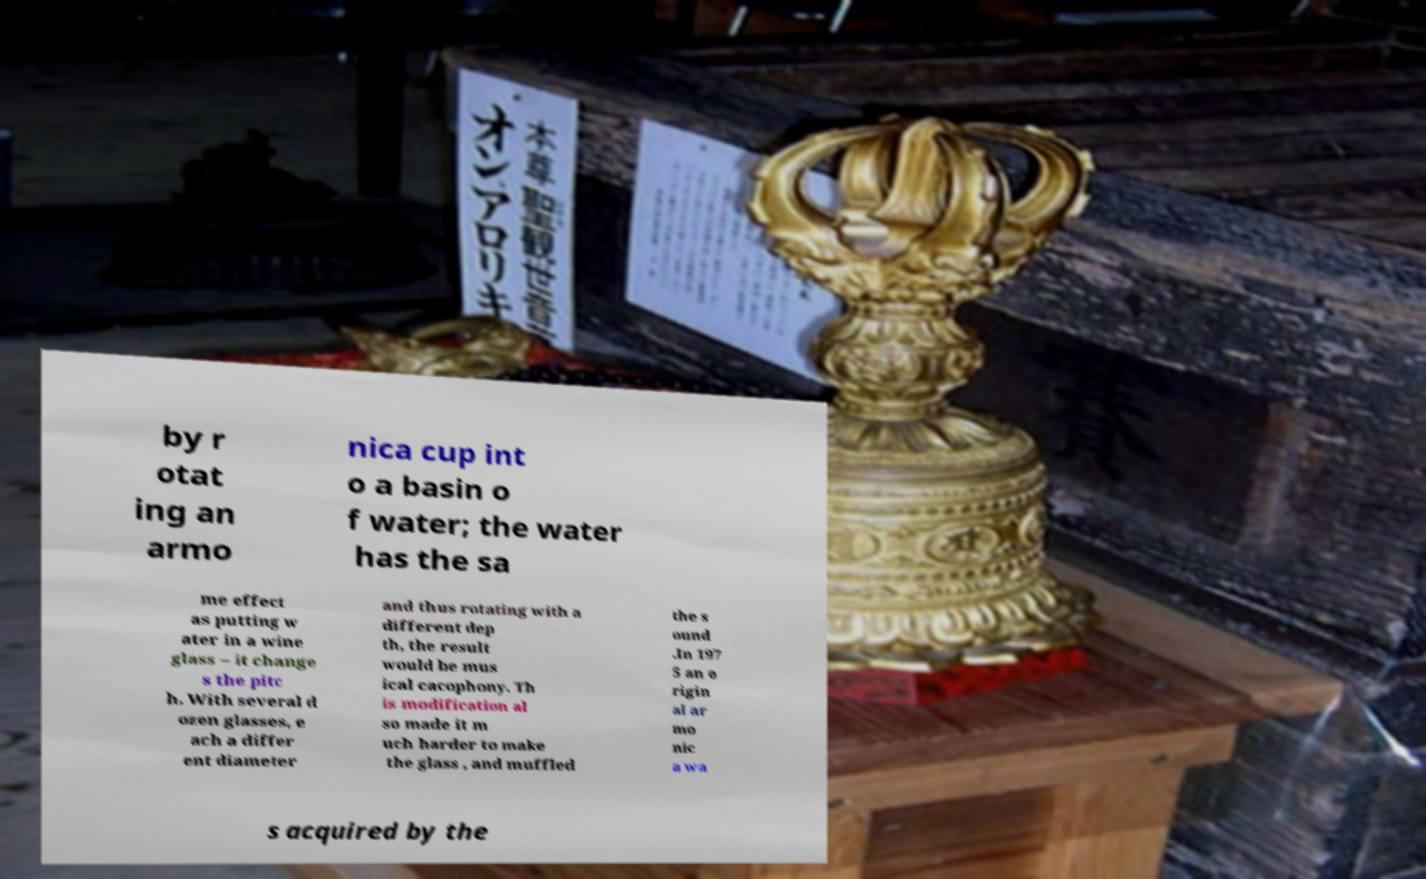Could you assist in decoding the text presented in this image and type it out clearly? by r otat ing an armo nica cup int o a basin o f water; the water has the sa me effect as putting w ater in a wine glass – it change s the pitc h. With several d ozen glasses, e ach a differ ent diameter and thus rotating with a different dep th, the result would be mus ical cacophony. Th is modification al so made it m uch harder to make the glass , and muffled the s ound .In 197 5 an o rigin al ar mo nic a wa s acquired by the 